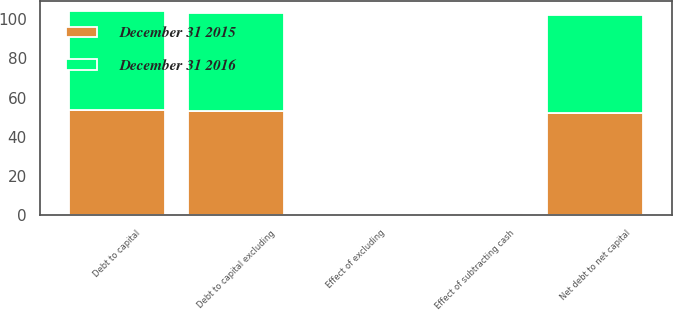Convert chart. <chart><loc_0><loc_0><loc_500><loc_500><stacked_bar_chart><ecel><fcel>Debt to capital<fcel>Effect of excluding<fcel>Debt to capital excluding<fcel>Effect of subtracting cash<fcel>Net debt to net capital<nl><fcel>December 31 2015<fcel>53.4<fcel>0.5<fcel>52.9<fcel>0.9<fcel>52<nl><fcel>December 31 2016<fcel>50.8<fcel>0.6<fcel>50.2<fcel>0.2<fcel>50<nl></chart> 